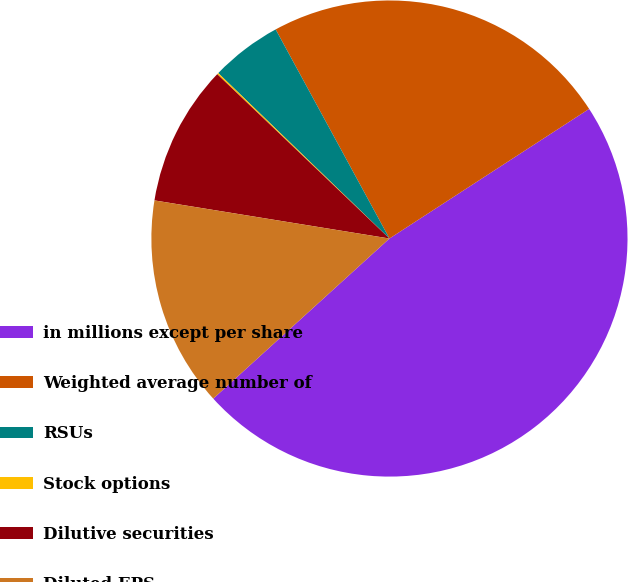<chart> <loc_0><loc_0><loc_500><loc_500><pie_chart><fcel>in millions except per share<fcel>Weighted average number of<fcel>RSUs<fcel>Stock options<fcel>Dilutive securities<fcel>Diluted EPS<nl><fcel>47.43%<fcel>23.77%<fcel>4.84%<fcel>0.1%<fcel>9.57%<fcel>14.3%<nl></chart> 